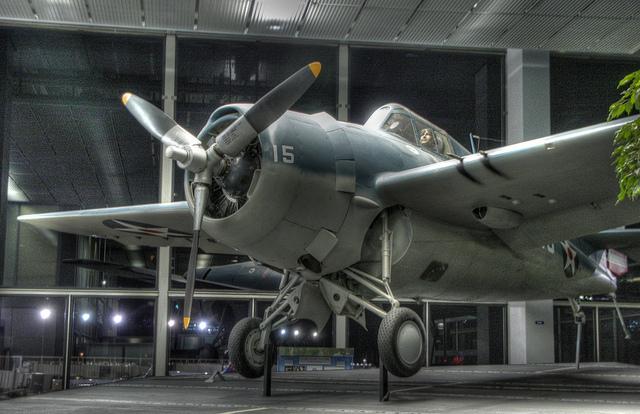Is the landing gear down?
Write a very short answer. Yes. Is this an airplane museum?
Concise answer only. Yes. How many blades on the propeller?
Give a very brief answer. 3. 